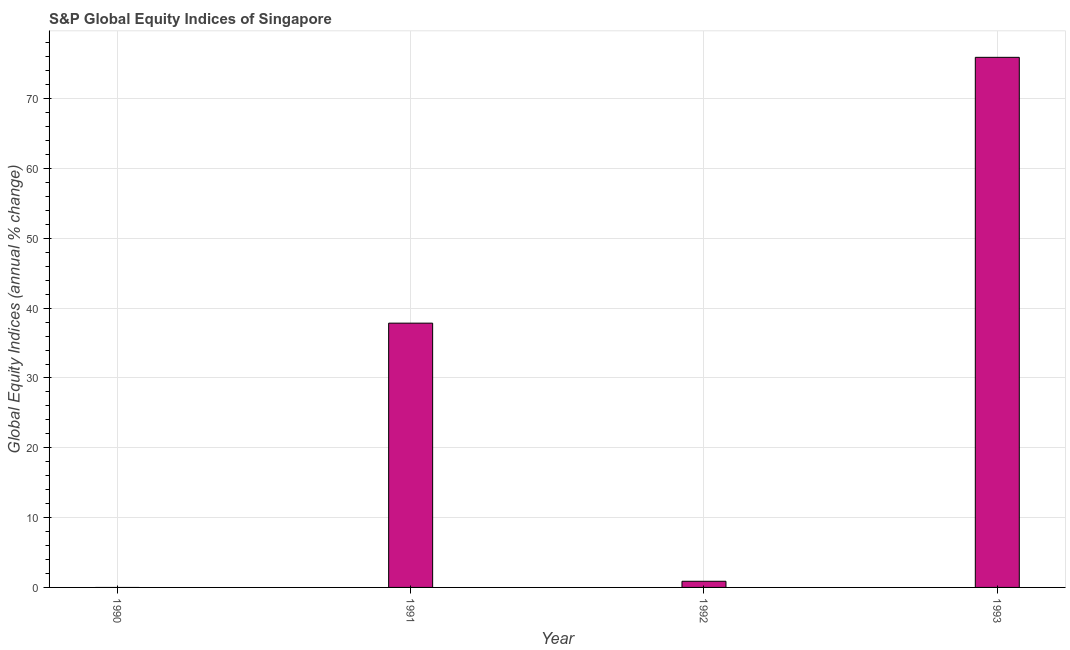Does the graph contain grids?
Offer a terse response. Yes. What is the title of the graph?
Your answer should be very brief. S&P Global Equity Indices of Singapore. What is the label or title of the X-axis?
Offer a very short reply. Year. What is the label or title of the Y-axis?
Offer a very short reply. Global Equity Indices (annual % change). Across all years, what is the maximum s&p global equity indices?
Your answer should be very brief. 75.93. What is the sum of the s&p global equity indices?
Offer a very short reply. 114.66. What is the difference between the s&p global equity indices in 1992 and 1993?
Provide a succinct answer. -75.05. What is the average s&p global equity indices per year?
Provide a succinct answer. 28.66. What is the median s&p global equity indices?
Your answer should be compact. 19.37. In how many years, is the s&p global equity indices greater than 10 %?
Provide a short and direct response. 2. What is the ratio of the s&p global equity indices in 1992 to that in 1993?
Ensure brevity in your answer.  0.01. What is the difference between the highest and the second highest s&p global equity indices?
Offer a very short reply. 38.07. Is the sum of the s&p global equity indices in 1992 and 1993 greater than the maximum s&p global equity indices across all years?
Offer a very short reply. Yes. What is the difference between the highest and the lowest s&p global equity indices?
Offer a terse response. 75.93. In how many years, is the s&p global equity indices greater than the average s&p global equity indices taken over all years?
Keep it short and to the point. 2. How many years are there in the graph?
Your answer should be compact. 4. What is the difference between two consecutive major ticks on the Y-axis?
Your answer should be compact. 10. Are the values on the major ticks of Y-axis written in scientific E-notation?
Offer a terse response. No. What is the Global Equity Indices (annual % change) in 1990?
Provide a succinct answer. 0. What is the Global Equity Indices (annual % change) in 1991?
Your answer should be very brief. 37.85. What is the Global Equity Indices (annual % change) of 1992?
Make the answer very short. 0.88. What is the Global Equity Indices (annual % change) of 1993?
Keep it short and to the point. 75.93. What is the difference between the Global Equity Indices (annual % change) in 1991 and 1992?
Your answer should be very brief. 36.97. What is the difference between the Global Equity Indices (annual % change) in 1991 and 1993?
Offer a very short reply. -38.07. What is the difference between the Global Equity Indices (annual % change) in 1992 and 1993?
Make the answer very short. -75.05. What is the ratio of the Global Equity Indices (annual % change) in 1991 to that in 1992?
Offer a very short reply. 42.97. What is the ratio of the Global Equity Indices (annual % change) in 1991 to that in 1993?
Your answer should be very brief. 0.5. What is the ratio of the Global Equity Indices (annual % change) in 1992 to that in 1993?
Give a very brief answer. 0.01. 